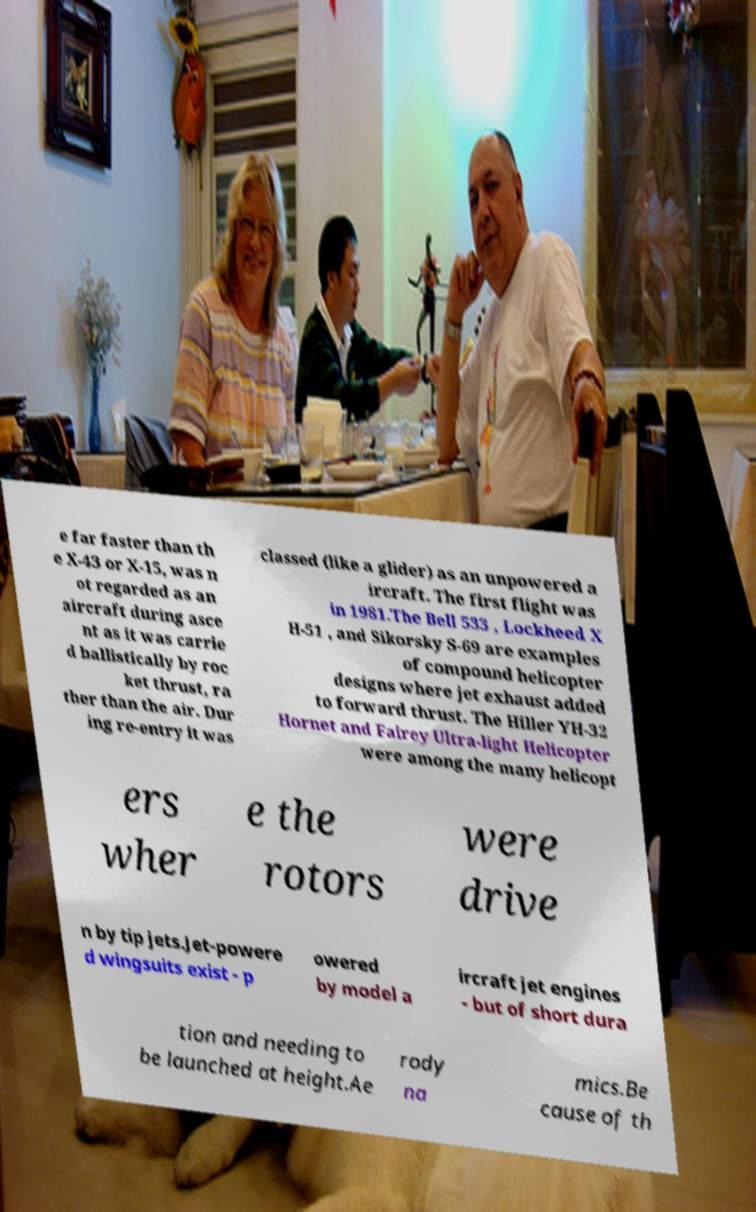I need the written content from this picture converted into text. Can you do that? e far faster than th e X-43 or X-15, was n ot regarded as an aircraft during asce nt as it was carrie d ballistically by roc ket thrust, ra ther than the air. Dur ing re-entry it was classed (like a glider) as an unpowered a ircraft. The first flight was in 1981.The Bell 533 , Lockheed X H-51 , and Sikorsky S-69 are examples of compound helicopter designs where jet exhaust added to forward thrust. The Hiller YH-32 Hornet and Fairey Ultra-light Helicopter were among the many helicopt ers wher e the rotors were drive n by tip jets.Jet-powere d wingsuits exist - p owered by model a ircraft jet engines - but of short dura tion and needing to be launched at height.Ae rody na mics.Be cause of th 